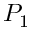Convert formula to latex. <formula><loc_0><loc_0><loc_500><loc_500>P _ { 1 }</formula> 